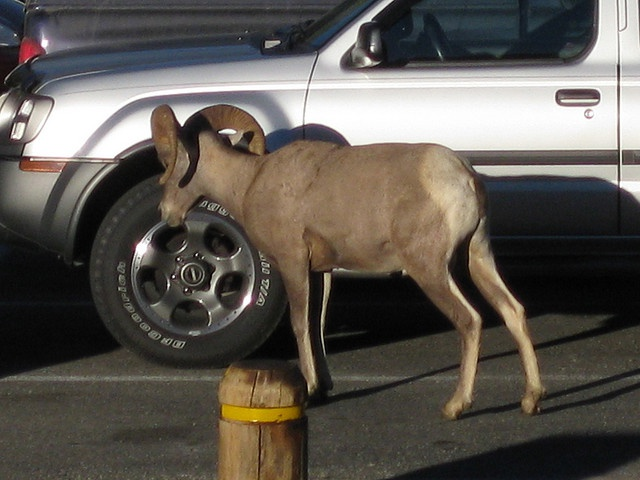Describe the objects in this image and their specific colors. I can see car in navy, black, white, gray, and darkgray tones, sheep in navy, gray, tan, and maroon tones, car in navy, gray, and black tones, and car in navy, black, darkblue, and gray tones in this image. 